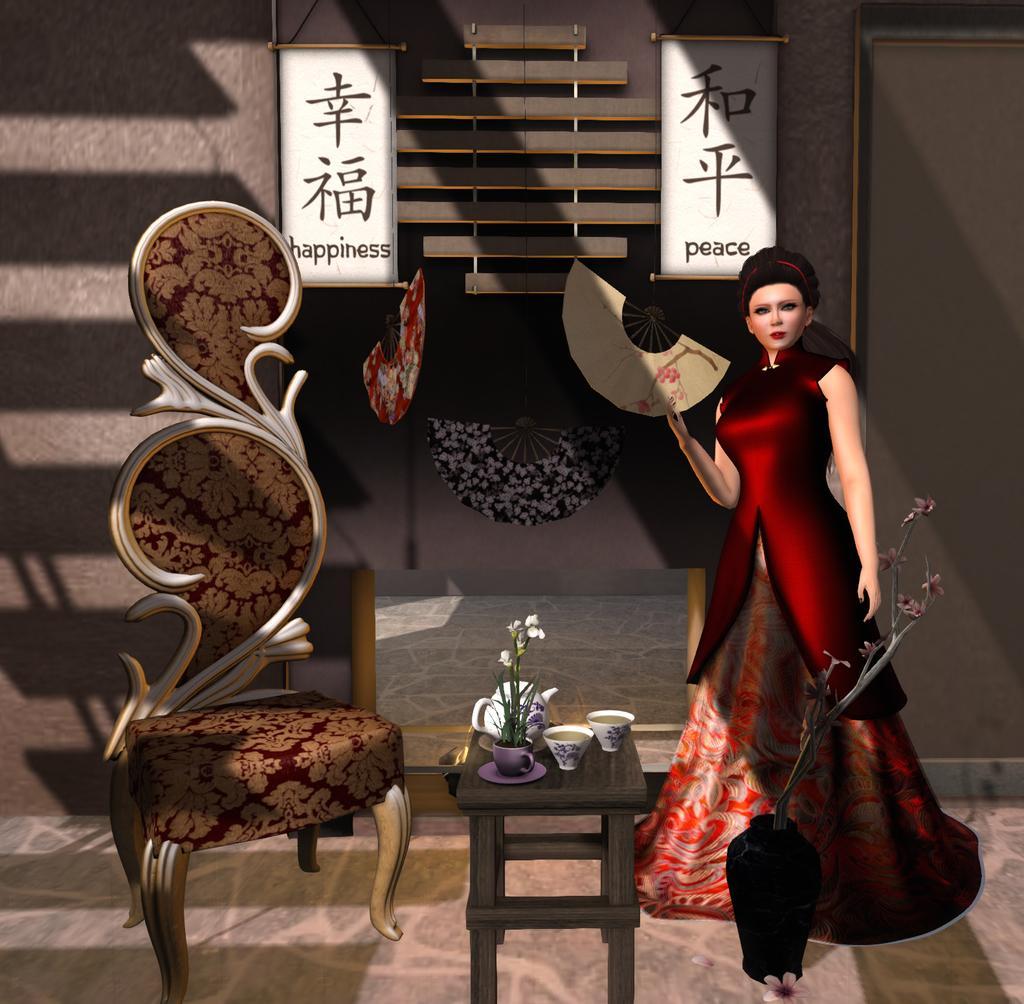Describe this image in one or two sentences. This is an animation and here we can see a lady and there are flower vases, a chair and some cups and a kettle are on the stool. In the background, there are decor items and we can see some boards with some text are on the wall. 